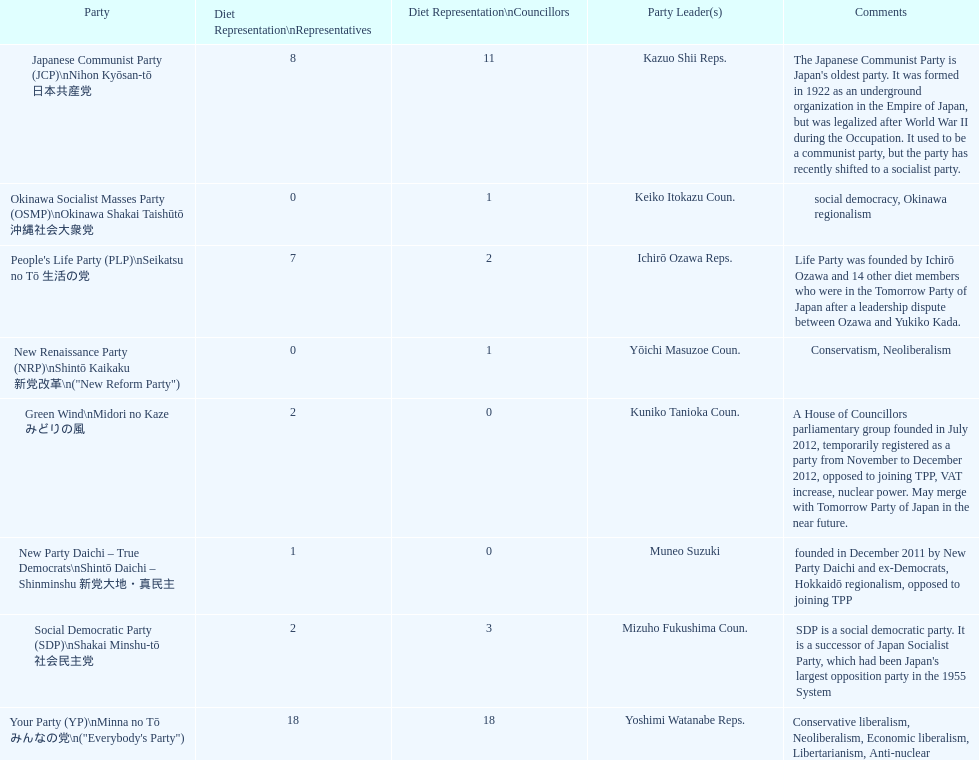According to this table, which party is japan's oldest political party? Japanese Communist Party (JCP) Nihon Kyōsan-tō 日本共産党. Write the full table. {'header': ['Party', 'Diet Representation\\nRepresentatives', 'Diet Representation\\nCouncillors', 'Party Leader(s)', 'Comments'], 'rows': [['Japanese Communist Party (JCP)\\nNihon Kyōsan-tō 日本共産党', '8', '11', 'Kazuo Shii Reps.', "The Japanese Communist Party is Japan's oldest party. It was formed in 1922 as an underground organization in the Empire of Japan, but was legalized after World War II during the Occupation. It used to be a communist party, but the party has recently shifted to a socialist party."], ['Okinawa Socialist Masses Party (OSMP)\\nOkinawa Shakai Taishūtō 沖縄社会大衆党', '0', '1', 'Keiko Itokazu Coun.', 'social democracy, Okinawa regionalism'], ["People's Life Party (PLP)\\nSeikatsu no Tō 生活の党", '7', '2', 'Ichirō Ozawa Reps.', 'Life Party was founded by Ichirō Ozawa and 14 other diet members who were in the Tomorrow Party of Japan after a leadership dispute between Ozawa and Yukiko Kada.'], ['New Renaissance Party (NRP)\\nShintō Kaikaku 新党改革\\n("New Reform Party")', '0', '1', 'Yōichi Masuzoe Coun.', 'Conservatism, Neoliberalism'], ['Green Wind\\nMidori no Kaze みどりの風', '2', '0', 'Kuniko Tanioka Coun.', 'A House of Councillors parliamentary group founded in July 2012, temporarily registered as a party from November to December 2012, opposed to joining TPP, VAT increase, nuclear power. May merge with Tomorrow Party of Japan in the near future.'], ['New Party Daichi – True Democrats\\nShintō Daichi – Shinminshu 新党大地・真民主', '1', '0', 'Muneo Suzuki', 'founded in December 2011 by New Party Daichi and ex-Democrats, Hokkaidō regionalism, opposed to joining TPP'], ['Social Democratic Party (SDP)\\nShakai Minshu-tō 社会民主党', '2', '3', 'Mizuho Fukushima Coun.', "SDP is a social democratic party. It is a successor of Japan Socialist Party, which had been Japan's largest opposition party in the 1955 System"], ['Your Party (YP)\\nMinna no Tō みんなの党\\n("Everybody\'s Party")', '18', '18', 'Yoshimi Watanabe Reps.', 'Conservative liberalism, Neoliberalism, Economic liberalism, Libertarianism, Anti-nuclear']]} 